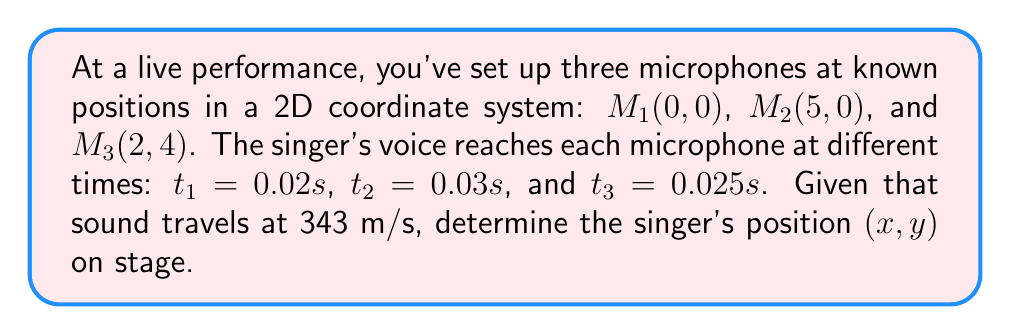Give your solution to this math problem. To solve this inverse problem, we'll use the time difference of arrival (TDOA) method:

1) First, calculate the distances from the singer to each microphone:
   $d_1 = 343 \cdot 0.02 = 6.86$ m
   $d_2 = 343 \cdot 0.03 = 10.29$ m
   $d_3 = 343 \cdot 0.025 = 8.575$ m

2) Set up equations based on the distance formula:
   $$(x-0)^2 + (y-0)^2 = 6.86^2$$
   $$(x-5)^2 + y^2 = 10.29^2$$
   $$(x-2)^2 + (y-4)^2 = 8.575^2$$

3) Simplify:
   $$x^2 + y^2 = 47.0596$$
   $$(x-5)^2 + y^2 = 105.8841$$
   $$(x-2)^2 + (y-4)^2 = 73.5306$$

4) Subtract the first equation from the second:
   $$x^2 - 10x + 25 = 58.8245$$
   $$x^2 - 10x - 33.8245 = 0$$

5) Solve this quadratic equation:
   $$x = \frac{10 \pm \sqrt{100 + 4(33.8245)}}{2} = \frac{10 \pm \sqrt{235.298}}{2}$$
   $$x \approx 8.68 \text{ or } 1.32$$

6) Use the first equation to find y:
   $$y^2 = 47.0596 - x^2$$
   
   For $x = 8.68$: $y^2 = -28.3268$ (invalid)
   For $x = 1.32$: $y^2 = 45.3128$, so $y \approx \pm 6.73$

7) Check which solution satisfies the third equation:
   $(1.32-2)^2 + (6.73-4)^2 \approx 73.5306$
   $(1.32-2)^2 + (-6.73-4)^2 \neq 73.5306$

Therefore, the singer's position is approximately (1.32, 6.73).
Answer: (1.32, 6.73) 